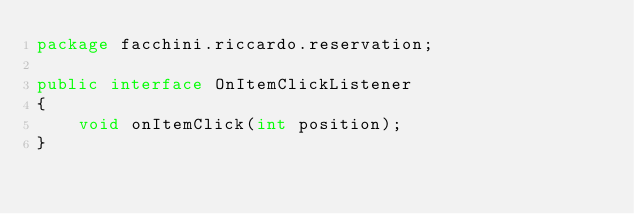<code> <loc_0><loc_0><loc_500><loc_500><_Java_>package facchini.riccardo.reservation;

public interface OnItemClickListener
{
    void onItemClick(int position);
}
</code> 